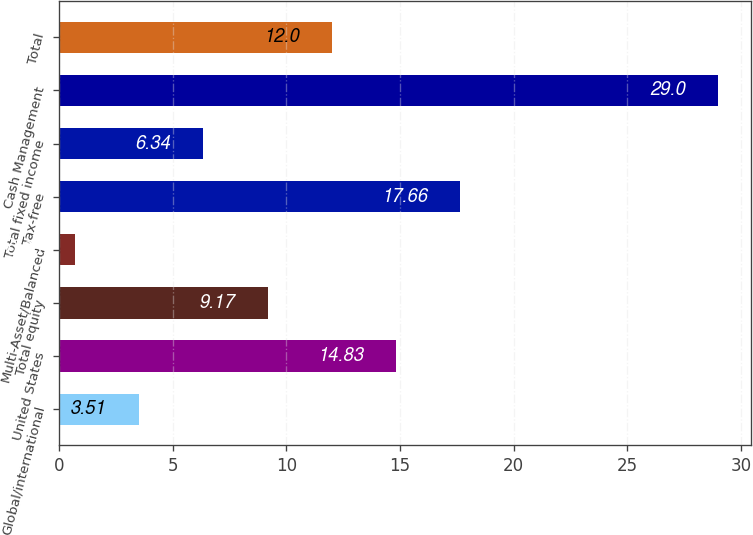Convert chart. <chart><loc_0><loc_0><loc_500><loc_500><bar_chart><fcel>Global/international<fcel>United States<fcel>Total equity<fcel>Multi-Asset/Balanced<fcel>Tax-free<fcel>Total fixed income<fcel>Cash Management<fcel>Total<nl><fcel>3.51<fcel>14.83<fcel>9.17<fcel>0.68<fcel>17.66<fcel>6.34<fcel>29<fcel>12<nl></chart> 